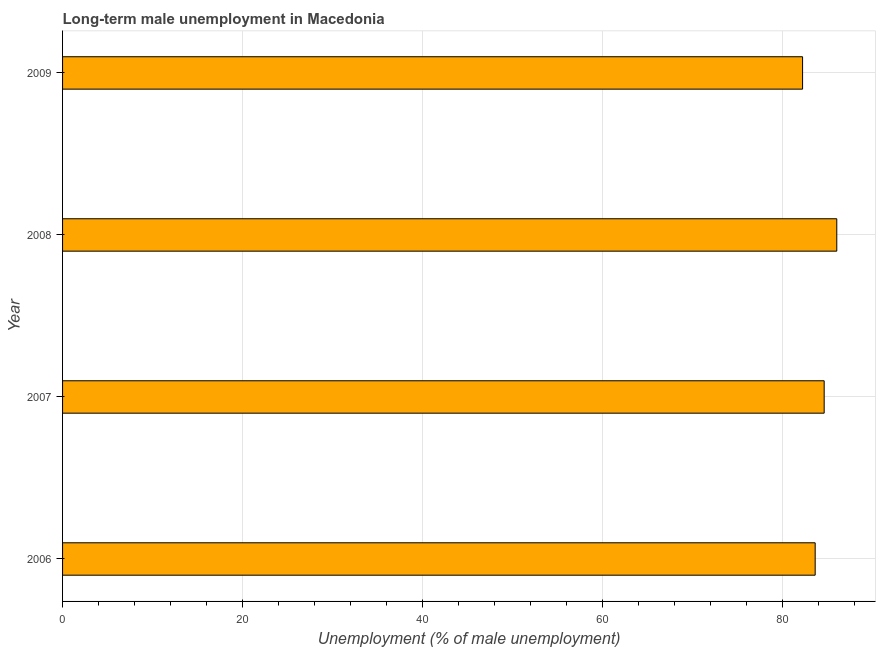Does the graph contain grids?
Your answer should be very brief. Yes. What is the title of the graph?
Your answer should be very brief. Long-term male unemployment in Macedonia. What is the label or title of the X-axis?
Ensure brevity in your answer.  Unemployment (% of male unemployment). Across all years, what is the maximum long-term male unemployment?
Offer a terse response. 86. Across all years, what is the minimum long-term male unemployment?
Offer a terse response. 82.2. In which year was the long-term male unemployment maximum?
Your answer should be very brief. 2008. In which year was the long-term male unemployment minimum?
Keep it short and to the point. 2009. What is the sum of the long-term male unemployment?
Give a very brief answer. 336.4. What is the difference between the long-term male unemployment in 2008 and 2009?
Make the answer very short. 3.8. What is the average long-term male unemployment per year?
Your response must be concise. 84.1. What is the median long-term male unemployment?
Make the answer very short. 84.1. In how many years, is the long-term male unemployment greater than 20 %?
Provide a succinct answer. 4. In how many years, is the long-term male unemployment greater than the average long-term male unemployment taken over all years?
Your answer should be very brief. 2. Are all the bars in the graph horizontal?
Your answer should be compact. Yes. How many years are there in the graph?
Your response must be concise. 4. What is the difference between two consecutive major ticks on the X-axis?
Your response must be concise. 20. What is the Unemployment (% of male unemployment) of 2006?
Provide a short and direct response. 83.6. What is the Unemployment (% of male unemployment) of 2007?
Offer a very short reply. 84.6. What is the Unemployment (% of male unemployment) in 2009?
Offer a very short reply. 82.2. What is the difference between the Unemployment (% of male unemployment) in 2006 and 2007?
Your response must be concise. -1. What is the difference between the Unemployment (% of male unemployment) in 2006 and 2008?
Your answer should be very brief. -2.4. What is the difference between the Unemployment (% of male unemployment) in 2006 and 2009?
Give a very brief answer. 1.4. What is the difference between the Unemployment (% of male unemployment) in 2007 and 2008?
Provide a short and direct response. -1.4. What is the difference between the Unemployment (% of male unemployment) in 2007 and 2009?
Your answer should be compact. 2.4. What is the ratio of the Unemployment (% of male unemployment) in 2006 to that in 2008?
Offer a terse response. 0.97. What is the ratio of the Unemployment (% of male unemployment) in 2006 to that in 2009?
Ensure brevity in your answer.  1.02. What is the ratio of the Unemployment (% of male unemployment) in 2007 to that in 2008?
Provide a short and direct response. 0.98. What is the ratio of the Unemployment (% of male unemployment) in 2008 to that in 2009?
Offer a terse response. 1.05. 